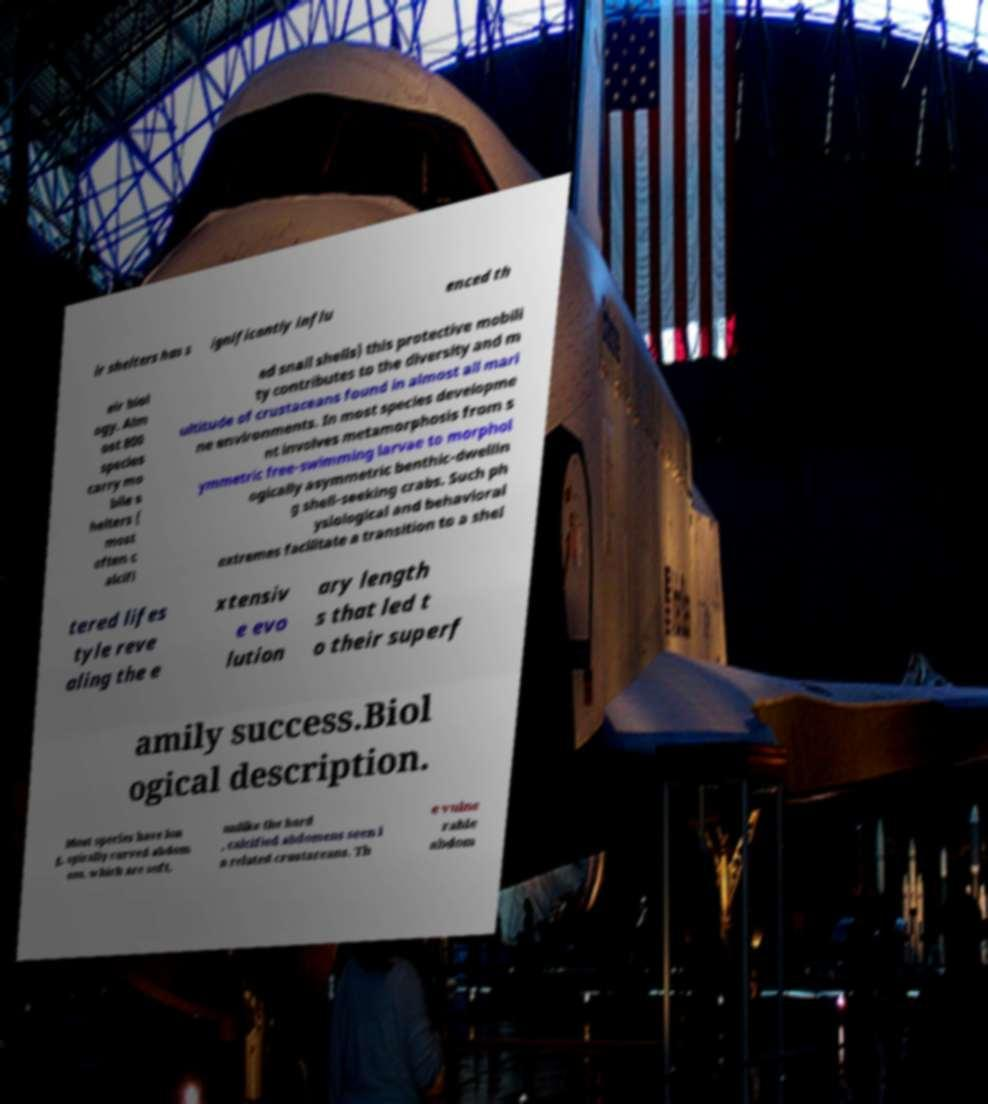Can you read and provide the text displayed in the image?This photo seems to have some interesting text. Can you extract and type it out for me? ir shelters has s ignificantly influ enced th eir biol ogy. Alm ost 800 species carry mo bile s helters ( most often c alcifi ed snail shells) this protective mobili ty contributes to the diversity and m ultitude of crustaceans found in almost all mari ne environments. In most species developme nt involves metamorphosis from s ymmetric free-swimming larvae to morphol ogically asymmetric benthic-dwellin g shell-seeking crabs. Such ph ysiological and behavioral extremes facilitate a transition to a shel tered lifes tyle reve aling the e xtensiv e evo lution ary length s that led t o their superf amily success.Biol ogical description. Most species have lon g, spirally curved abdom ens, which are soft, unlike the hard , calcified abdomens seen i n related crustaceans. Th e vulne rable abdom 